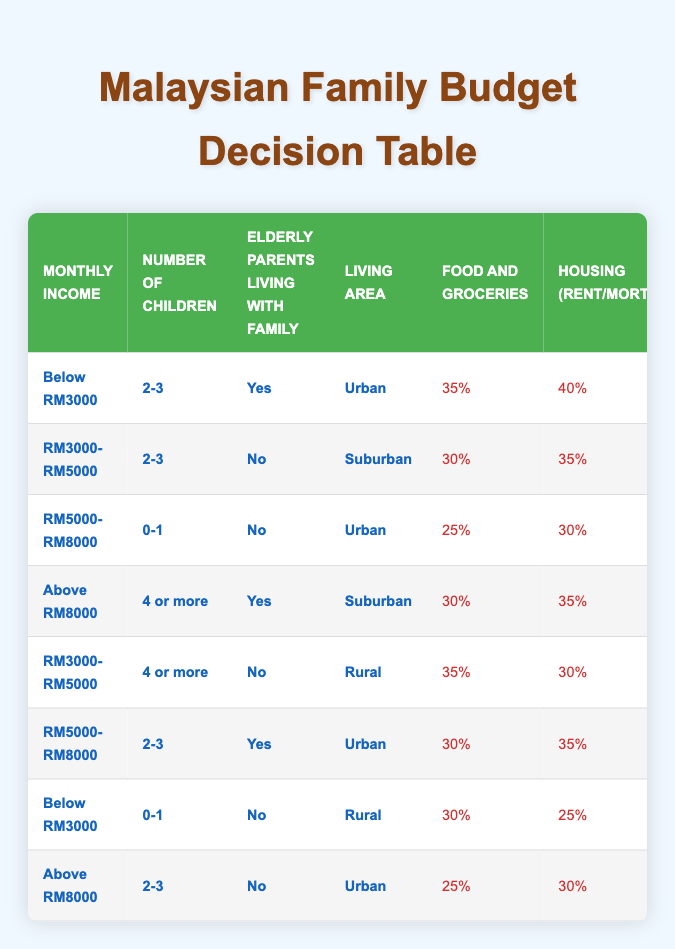What are the priorities for a family with a monthly income below RM3000, 2-3 children, elderly parents living with them, and living in an urban area? According to the table, for this scenario, the budget allocation is: Food and Groceries 35%, Housing 40%, Utilities 10%, Transportation 8%, Healthcare 5%, Education 5%, Savings 5%, and Family Activities 2%.
Answer: Food 35%, Housing 40%, Utilities 10%, Transportation 8%, Healthcare 5%, Education 5%, Savings 5%, Family Activities 2% Is healthcare a higher priority than transportation for families with a monthly income of RM5000 to RM8000 and 0-1 children living in urban areas? For families with a monthly income of RM5000 to RM8000 and 0-1 children living in urban areas, healthcare is allocated 8% and transportation is 12%. Since 12% (Transportation) is higher than 8% (Healthcare), the answer is no.
Answer: No How much is allocated for savings and education for families earning above RM8000, with 2-3 children, and living in urban areas? For families in this income bracket with 2-3 children in urban areas, savings is set at 20% and education at 15%. This gives us the specific values as follows: Savings 20% and Education 15%.
Answer: Savings 20%, Education 15% What is the total percentage allocated for housing and food for families earning RM3000 to RM5000 with 4 or more children residing in rural areas? According to the table, families in this situation allocate 35% for food and 30% for housing. Summing these values gives us a total of 35% + 30% = 65% for housing and food combined.
Answer: 65% Do families living in suburban areas with a monthly income of RM3000 to RM5000 and 2-3 children prioritize education over family activities? For this demographic segment, education allocation is 10% while family activities allocation is 5%. Since 10% (Education) is greater than 5% (Family Activities), the answer is yes.
Answer: Yes What is the highest percentage allocated for housing and which income group does it apply to? The highest percentage allocated for housing is 40%, applicable to families earning below RM3000, with 2-3 children, living with elderly parents in urban areas.
Answer: 40%, below RM3000 